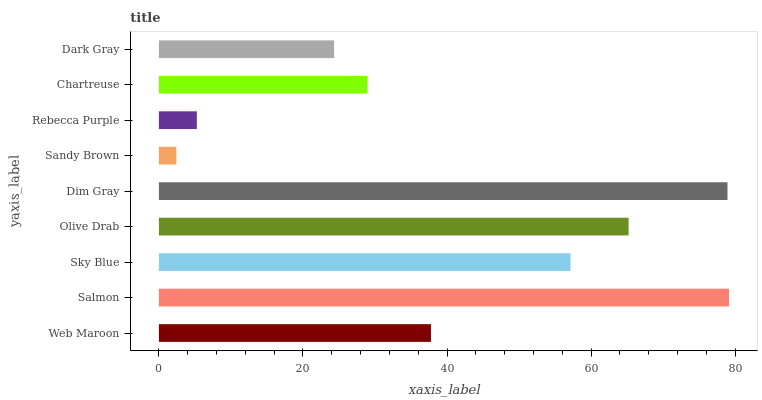Is Sandy Brown the minimum?
Answer yes or no. Yes. Is Salmon the maximum?
Answer yes or no. Yes. Is Sky Blue the minimum?
Answer yes or no. No. Is Sky Blue the maximum?
Answer yes or no. No. Is Salmon greater than Sky Blue?
Answer yes or no. Yes. Is Sky Blue less than Salmon?
Answer yes or no. Yes. Is Sky Blue greater than Salmon?
Answer yes or no. No. Is Salmon less than Sky Blue?
Answer yes or no. No. Is Web Maroon the high median?
Answer yes or no. Yes. Is Web Maroon the low median?
Answer yes or no. Yes. Is Rebecca Purple the high median?
Answer yes or no. No. Is Dim Gray the low median?
Answer yes or no. No. 